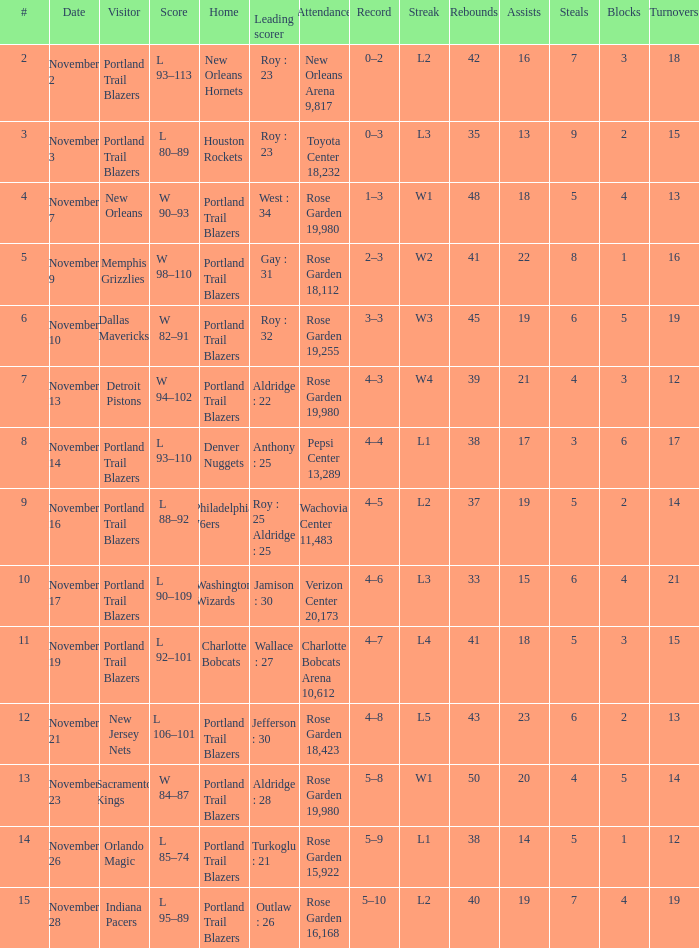Give me the full table as a dictionary. {'header': ['#', 'Date', 'Visitor', 'Score', 'Home', 'Leading scorer', 'Attendance', 'Record', 'Streak', 'Rebounds', 'Assists', 'Steals', 'Blocks', 'Turnovers'], 'rows': [['2', 'November 2', 'Portland Trail Blazers', 'L 93–113', 'New Orleans Hornets', 'Roy : 23', 'New Orleans Arena 9,817', '0–2', 'L2', '42', '16', '7', '3', '18'], ['3', 'November 3', 'Portland Trail Blazers', 'L 80–89', 'Houston Rockets', 'Roy : 23', 'Toyota Center 18,232', '0–3', 'L3', '35', '13', '9', '2', '15'], ['4', 'November 7', 'New Orleans', 'W 90–93', 'Portland Trail Blazers', 'West : 34', 'Rose Garden 19,980', '1–3', 'W1', '48', '18', '5', '4', '13'], ['5', 'November 9', 'Memphis Grizzlies', 'W 98–110', 'Portland Trail Blazers', 'Gay : 31', 'Rose Garden 18,112', '2–3', 'W2', '41', '22', '8', '1', '16'], ['6', 'November 10', 'Dallas Mavericks', 'W 82–91', 'Portland Trail Blazers', 'Roy : 32', 'Rose Garden 19,255', '3–3', 'W3', '45', '19', '6', '5', '19'], ['7', 'November 13', 'Detroit Pistons', 'W 94–102', 'Portland Trail Blazers', 'Aldridge : 22', 'Rose Garden 19,980', '4–3', 'W4', '39', '21', '4', '3', '12'], ['8', 'November 14', 'Portland Trail Blazers', 'L 93–110', 'Denver Nuggets', 'Anthony : 25', 'Pepsi Center 13,289', '4–4', 'L1', '38', '17', '3', '6', '17'], ['9', 'November 16', 'Portland Trail Blazers', 'L 88–92', 'Philadelphia 76ers', 'Roy : 25 Aldridge : 25', 'Wachovia Center 11,483', '4–5', 'L2', '37', '19', '5', '2', '14'], ['10', 'November 17', 'Portland Trail Blazers', 'L 90–109', 'Washington Wizards', 'Jamison : 30', 'Verizon Center 20,173', '4–6', 'L3', '33', '15', '6', '4', '21'], ['11', 'November 19', 'Portland Trail Blazers', 'L 92–101', 'Charlotte Bobcats', 'Wallace : 27', 'Charlotte Bobcats Arena 10,612', '4–7', 'L4', '41', '18', '5', '3', '15'], ['12', 'November 21', 'New Jersey Nets', 'L 106–101', 'Portland Trail Blazers', 'Jefferson : 30', 'Rose Garden 18,423', '4–8', 'L5', '43', '23', '6', '2', '13'], ['13', 'November 23', 'Sacramento Kings', 'W 84–87', 'Portland Trail Blazers', 'Aldridge : 28', 'Rose Garden 19,980', '5–8', 'W1', '50', '20', '4', '5', '14'], ['14', 'November 26', 'Orlando Magic', 'L 85–74', 'Portland Trail Blazers', 'Turkoglu : 21', 'Rose Garden 15,922', '5–9', 'L1', '38', '14', '5', '1', '12'], ['15', 'November 28', 'Indiana Pacers', 'L 95–89', 'Portland Trail Blazers', 'Outlaw : 26', 'Rose Garden 16,168', '5–10', 'L2', '40', '19', '7', '4', '19']]}  what's the attendance where score is l 92–101 Charlotte Bobcats Arena 10,612. 